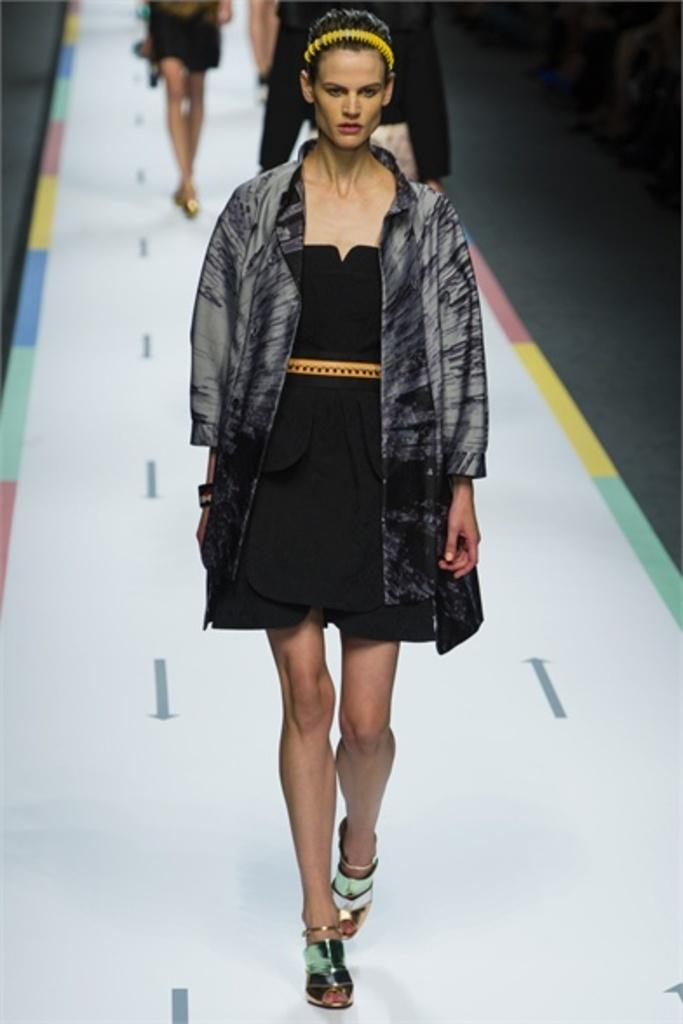What is present in the image? There are women in the image. What are the women doing in the image? The women are walking on a ramp. What type of cast can be seen on the women's arms in the image? There is no cast visible on the women's arms in the image. What kind of wax is being used by the women in the image? There is no wax present in the image. 